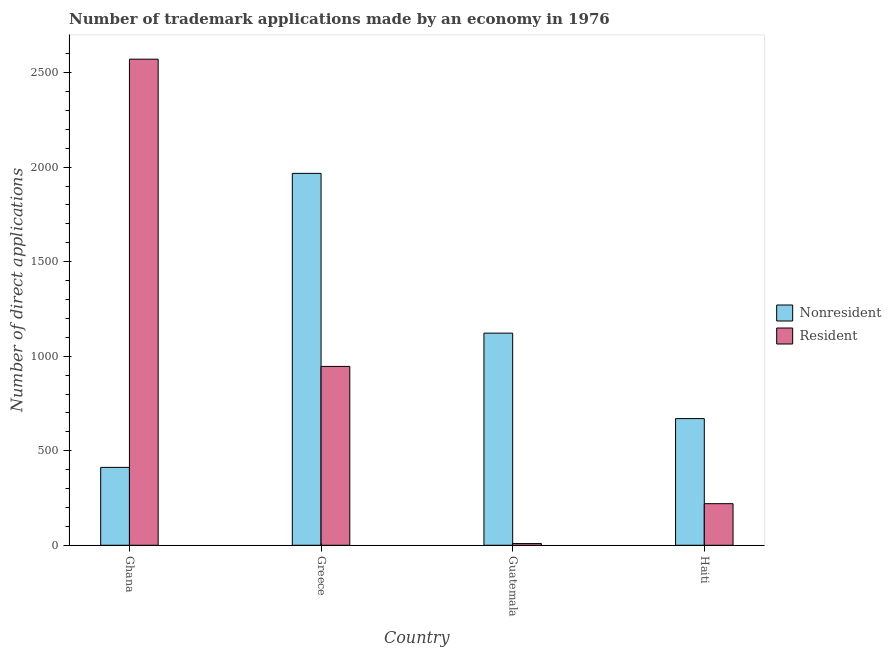How many different coloured bars are there?
Provide a succinct answer. 2. How many bars are there on the 2nd tick from the left?
Provide a short and direct response. 2. How many bars are there on the 3rd tick from the right?
Give a very brief answer. 2. What is the label of the 4th group of bars from the left?
Ensure brevity in your answer.  Haiti. What is the number of trademark applications made by residents in Guatemala?
Make the answer very short. 9. Across all countries, what is the maximum number of trademark applications made by non residents?
Provide a short and direct response. 1967. Across all countries, what is the minimum number of trademark applications made by non residents?
Ensure brevity in your answer.  412. In which country was the number of trademark applications made by non residents maximum?
Your answer should be very brief. Greece. In which country was the number of trademark applications made by residents minimum?
Provide a succinct answer. Guatemala. What is the total number of trademark applications made by residents in the graph?
Keep it short and to the point. 3746. What is the difference between the number of trademark applications made by residents in Greece and that in Guatemala?
Provide a succinct answer. 937. What is the difference between the number of trademark applications made by non residents in Ghana and the number of trademark applications made by residents in Greece?
Your answer should be very brief. -534. What is the average number of trademark applications made by residents per country?
Give a very brief answer. 936.5. What is the difference between the number of trademark applications made by non residents and number of trademark applications made by residents in Greece?
Keep it short and to the point. 1021. What is the ratio of the number of trademark applications made by non residents in Guatemala to that in Haiti?
Your response must be concise. 1.67. What is the difference between the highest and the second highest number of trademark applications made by residents?
Provide a succinct answer. 1625. What is the difference between the highest and the lowest number of trademark applications made by residents?
Provide a short and direct response. 2562. What does the 2nd bar from the left in Greece represents?
Keep it short and to the point. Resident. What does the 2nd bar from the right in Ghana represents?
Your answer should be very brief. Nonresident. How many bars are there?
Provide a short and direct response. 8. Are all the bars in the graph horizontal?
Make the answer very short. No. Does the graph contain grids?
Your answer should be compact. No. How many legend labels are there?
Provide a short and direct response. 2. What is the title of the graph?
Ensure brevity in your answer.  Number of trademark applications made by an economy in 1976. What is the label or title of the Y-axis?
Offer a very short reply. Number of direct applications. What is the Number of direct applications in Nonresident in Ghana?
Make the answer very short. 412. What is the Number of direct applications in Resident in Ghana?
Your response must be concise. 2571. What is the Number of direct applications of Nonresident in Greece?
Make the answer very short. 1967. What is the Number of direct applications in Resident in Greece?
Make the answer very short. 946. What is the Number of direct applications of Nonresident in Guatemala?
Offer a very short reply. 1122. What is the Number of direct applications of Nonresident in Haiti?
Make the answer very short. 670. What is the Number of direct applications of Resident in Haiti?
Keep it short and to the point. 220. Across all countries, what is the maximum Number of direct applications of Nonresident?
Offer a terse response. 1967. Across all countries, what is the maximum Number of direct applications in Resident?
Your answer should be very brief. 2571. Across all countries, what is the minimum Number of direct applications in Nonresident?
Your answer should be compact. 412. What is the total Number of direct applications in Nonresident in the graph?
Keep it short and to the point. 4171. What is the total Number of direct applications of Resident in the graph?
Offer a very short reply. 3746. What is the difference between the Number of direct applications in Nonresident in Ghana and that in Greece?
Your response must be concise. -1555. What is the difference between the Number of direct applications in Resident in Ghana and that in Greece?
Make the answer very short. 1625. What is the difference between the Number of direct applications in Nonresident in Ghana and that in Guatemala?
Give a very brief answer. -710. What is the difference between the Number of direct applications of Resident in Ghana and that in Guatemala?
Make the answer very short. 2562. What is the difference between the Number of direct applications of Nonresident in Ghana and that in Haiti?
Provide a short and direct response. -258. What is the difference between the Number of direct applications in Resident in Ghana and that in Haiti?
Your response must be concise. 2351. What is the difference between the Number of direct applications in Nonresident in Greece and that in Guatemala?
Your answer should be compact. 845. What is the difference between the Number of direct applications of Resident in Greece and that in Guatemala?
Give a very brief answer. 937. What is the difference between the Number of direct applications of Nonresident in Greece and that in Haiti?
Your answer should be compact. 1297. What is the difference between the Number of direct applications of Resident in Greece and that in Haiti?
Provide a succinct answer. 726. What is the difference between the Number of direct applications in Nonresident in Guatemala and that in Haiti?
Provide a short and direct response. 452. What is the difference between the Number of direct applications in Resident in Guatemala and that in Haiti?
Give a very brief answer. -211. What is the difference between the Number of direct applications of Nonresident in Ghana and the Number of direct applications of Resident in Greece?
Your answer should be compact. -534. What is the difference between the Number of direct applications in Nonresident in Ghana and the Number of direct applications in Resident in Guatemala?
Your answer should be compact. 403. What is the difference between the Number of direct applications of Nonresident in Ghana and the Number of direct applications of Resident in Haiti?
Offer a very short reply. 192. What is the difference between the Number of direct applications in Nonresident in Greece and the Number of direct applications in Resident in Guatemala?
Offer a very short reply. 1958. What is the difference between the Number of direct applications of Nonresident in Greece and the Number of direct applications of Resident in Haiti?
Offer a terse response. 1747. What is the difference between the Number of direct applications in Nonresident in Guatemala and the Number of direct applications in Resident in Haiti?
Keep it short and to the point. 902. What is the average Number of direct applications of Nonresident per country?
Keep it short and to the point. 1042.75. What is the average Number of direct applications in Resident per country?
Give a very brief answer. 936.5. What is the difference between the Number of direct applications of Nonresident and Number of direct applications of Resident in Ghana?
Offer a very short reply. -2159. What is the difference between the Number of direct applications of Nonresident and Number of direct applications of Resident in Greece?
Keep it short and to the point. 1021. What is the difference between the Number of direct applications of Nonresident and Number of direct applications of Resident in Guatemala?
Offer a very short reply. 1113. What is the difference between the Number of direct applications of Nonresident and Number of direct applications of Resident in Haiti?
Keep it short and to the point. 450. What is the ratio of the Number of direct applications in Nonresident in Ghana to that in Greece?
Offer a very short reply. 0.21. What is the ratio of the Number of direct applications of Resident in Ghana to that in Greece?
Offer a terse response. 2.72. What is the ratio of the Number of direct applications of Nonresident in Ghana to that in Guatemala?
Your response must be concise. 0.37. What is the ratio of the Number of direct applications in Resident in Ghana to that in Guatemala?
Provide a short and direct response. 285.67. What is the ratio of the Number of direct applications in Nonresident in Ghana to that in Haiti?
Give a very brief answer. 0.61. What is the ratio of the Number of direct applications of Resident in Ghana to that in Haiti?
Your answer should be very brief. 11.69. What is the ratio of the Number of direct applications of Nonresident in Greece to that in Guatemala?
Provide a short and direct response. 1.75. What is the ratio of the Number of direct applications in Resident in Greece to that in Guatemala?
Provide a succinct answer. 105.11. What is the ratio of the Number of direct applications in Nonresident in Greece to that in Haiti?
Give a very brief answer. 2.94. What is the ratio of the Number of direct applications of Nonresident in Guatemala to that in Haiti?
Offer a very short reply. 1.67. What is the ratio of the Number of direct applications of Resident in Guatemala to that in Haiti?
Offer a terse response. 0.04. What is the difference between the highest and the second highest Number of direct applications in Nonresident?
Your answer should be compact. 845. What is the difference between the highest and the second highest Number of direct applications in Resident?
Provide a succinct answer. 1625. What is the difference between the highest and the lowest Number of direct applications in Nonresident?
Your answer should be very brief. 1555. What is the difference between the highest and the lowest Number of direct applications of Resident?
Your answer should be very brief. 2562. 